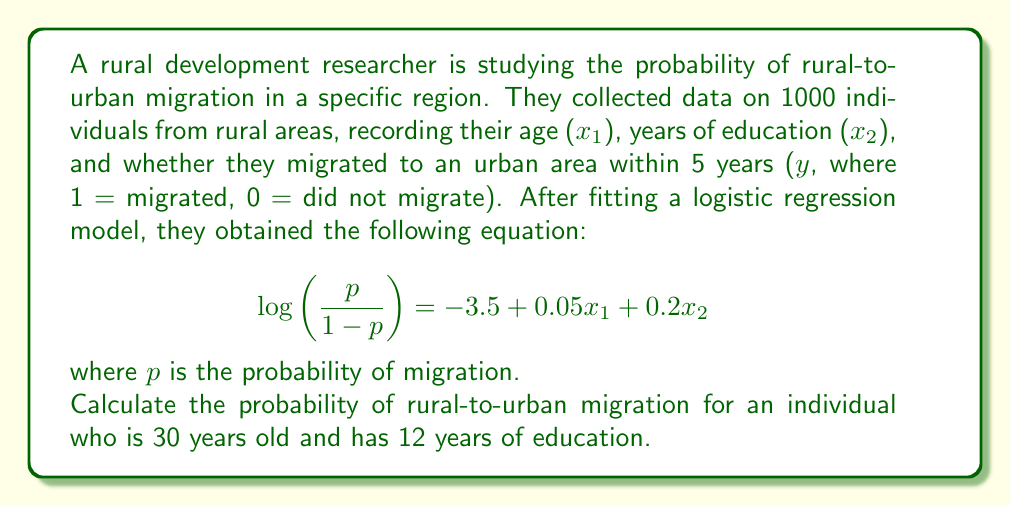Show me your answer to this math problem. To solve this problem, we'll follow these steps:

1) We have the logistic regression equation:
   $$ \log\left(\frac{p}{1-p}\right) = -3.5 + 0.05x_1 + 0.2x_2 $$

2) Substitute the given values:
   $x_1 = 30$ (age)
   $x_2 = 12$ (years of education)

3) Calculate the log-odds:
   $$ \log\left(\frac{p}{1-p}\right) = -3.5 + 0.05(30) + 0.2(12) $$
   $$ = -3.5 + 1.5 + 2.4 = 0.4 $$

4) The log-odds is 0.4. To get the probability, we need to apply the inverse logit function:
   $$ p = \frac{e^{0.4}}{1 + e^{0.4}} $$

5) Calculate this value:
   $$ p = \frac{e^{0.4}}{1 + e^{0.4}} = \frac{1.4918}{2.4918} \approx 0.5987 $$

6) Convert to a percentage:
   $0.5987 * 100\% = 59.87\%$

Therefore, the probability of rural-to-urban migration for an individual who is 30 years old and has 12 years of education is approximately 59.87%.
Answer: 59.87% 